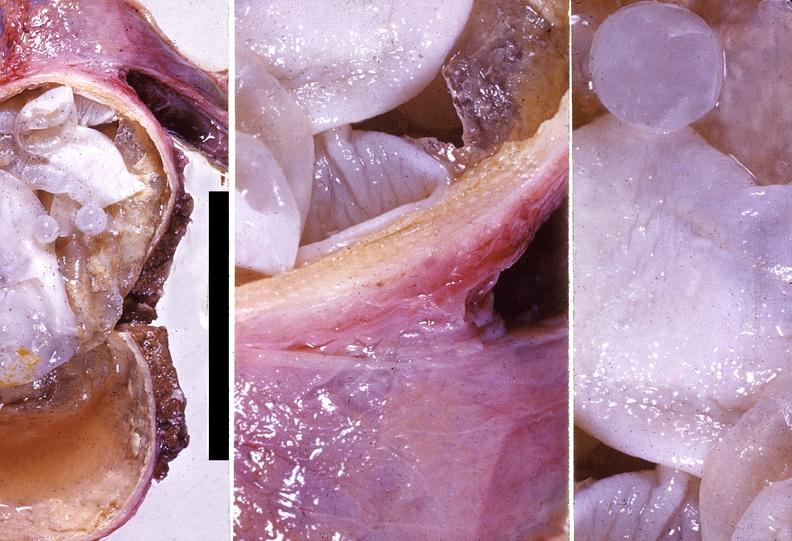s fixed tissue present?
Answer the question using a single word or phrase. No 